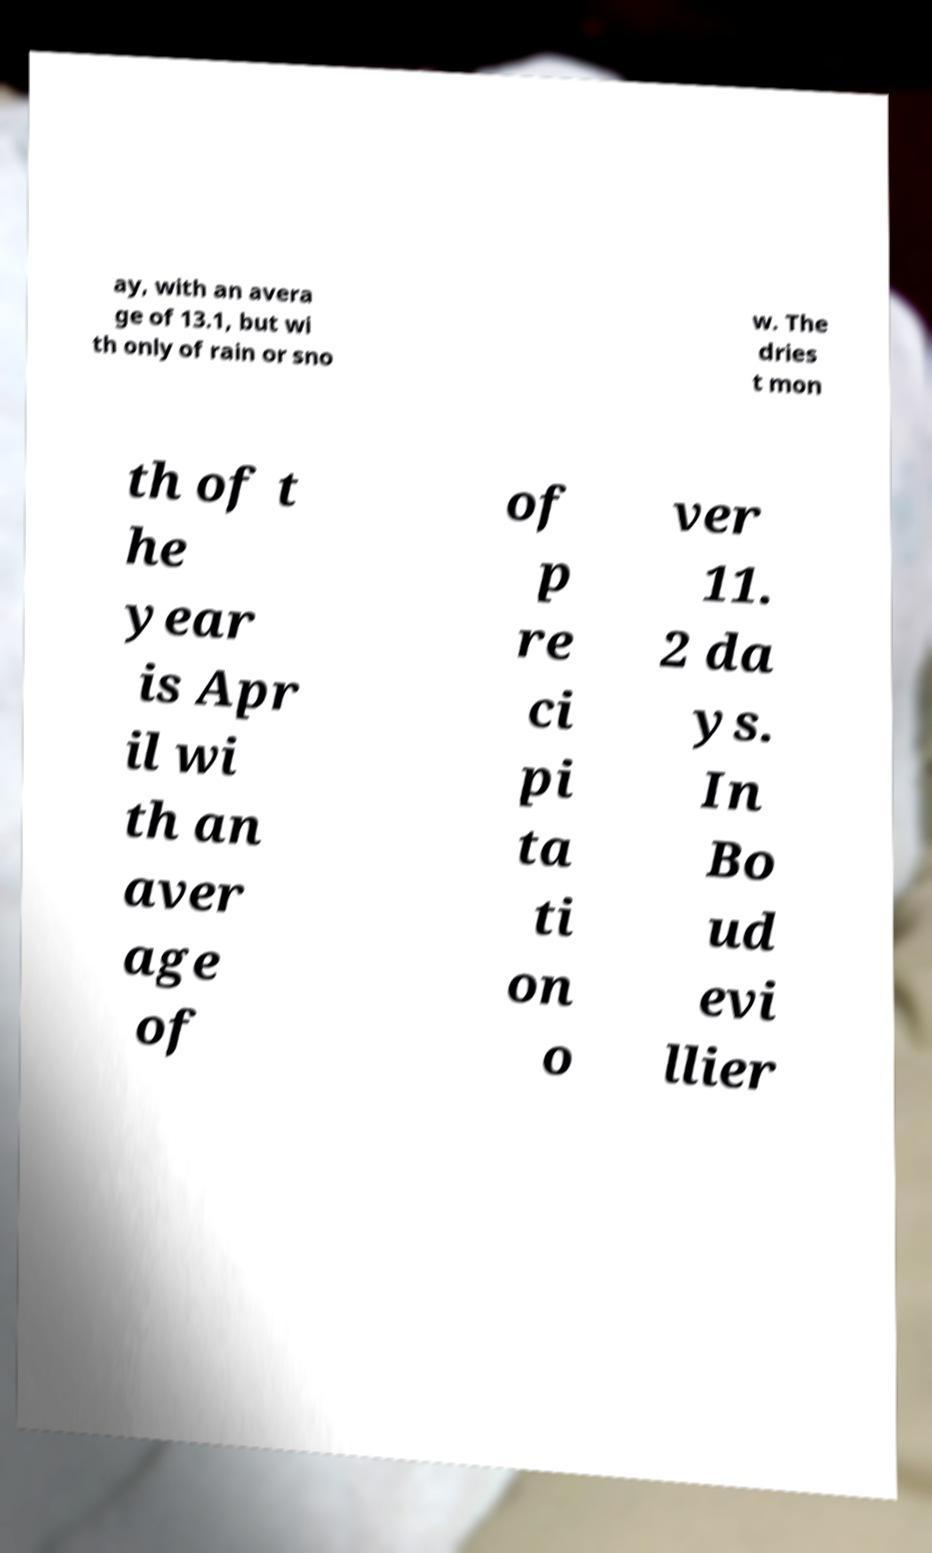I need the written content from this picture converted into text. Can you do that? ay, with an avera ge of 13.1, but wi th only of rain or sno w. The dries t mon th of t he year is Apr il wi th an aver age of of p re ci pi ta ti on o ver 11. 2 da ys. In Bo ud evi llier 